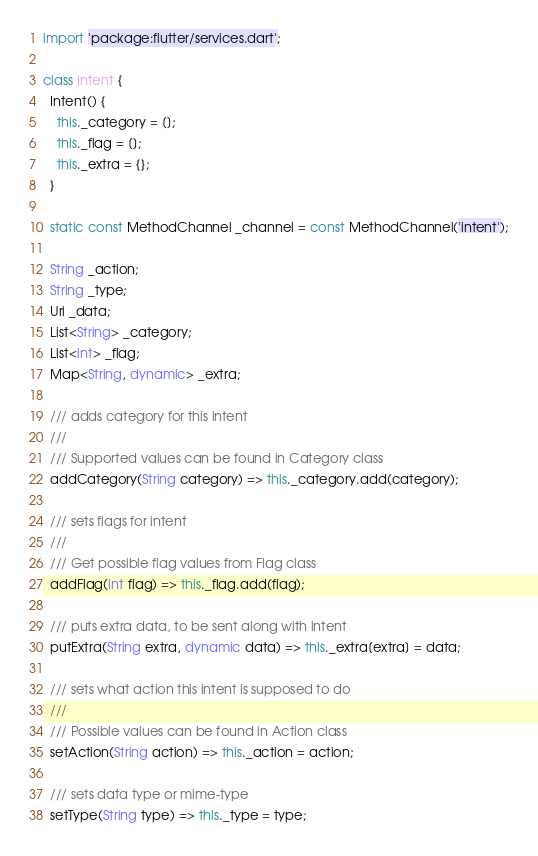Convert code to text. <code><loc_0><loc_0><loc_500><loc_500><_Dart_>import 'package:flutter/services.dart';

class Intent {
  Intent() {
    this._category = [];
    this._flag = [];
    this._extra = {};
  }

  static const MethodChannel _channel = const MethodChannel('intent');

  String _action;
  String _type;
  Uri _data;
  List<String> _category;
  List<int> _flag;
  Map<String, dynamic> _extra;

  /// adds category for this intent
  ///
  /// Supported values can be found in Category class
  addCategory(String category) => this._category.add(category);

  /// sets flags for intent
  ///
  /// Get possible flag values from Flag class
  addFlag(int flag) => this._flag.add(flag);

  /// puts extra data, to be sent along with intent
  putExtra(String extra, dynamic data) => this._extra[extra] = data;

  /// sets what action this intent is supposed to do
  ///
  /// Possible values can be found in Action class
  setAction(String action) => this._action = action;

  /// sets data type or mime-type
  setType(String type) => this._type = type;
</code> 